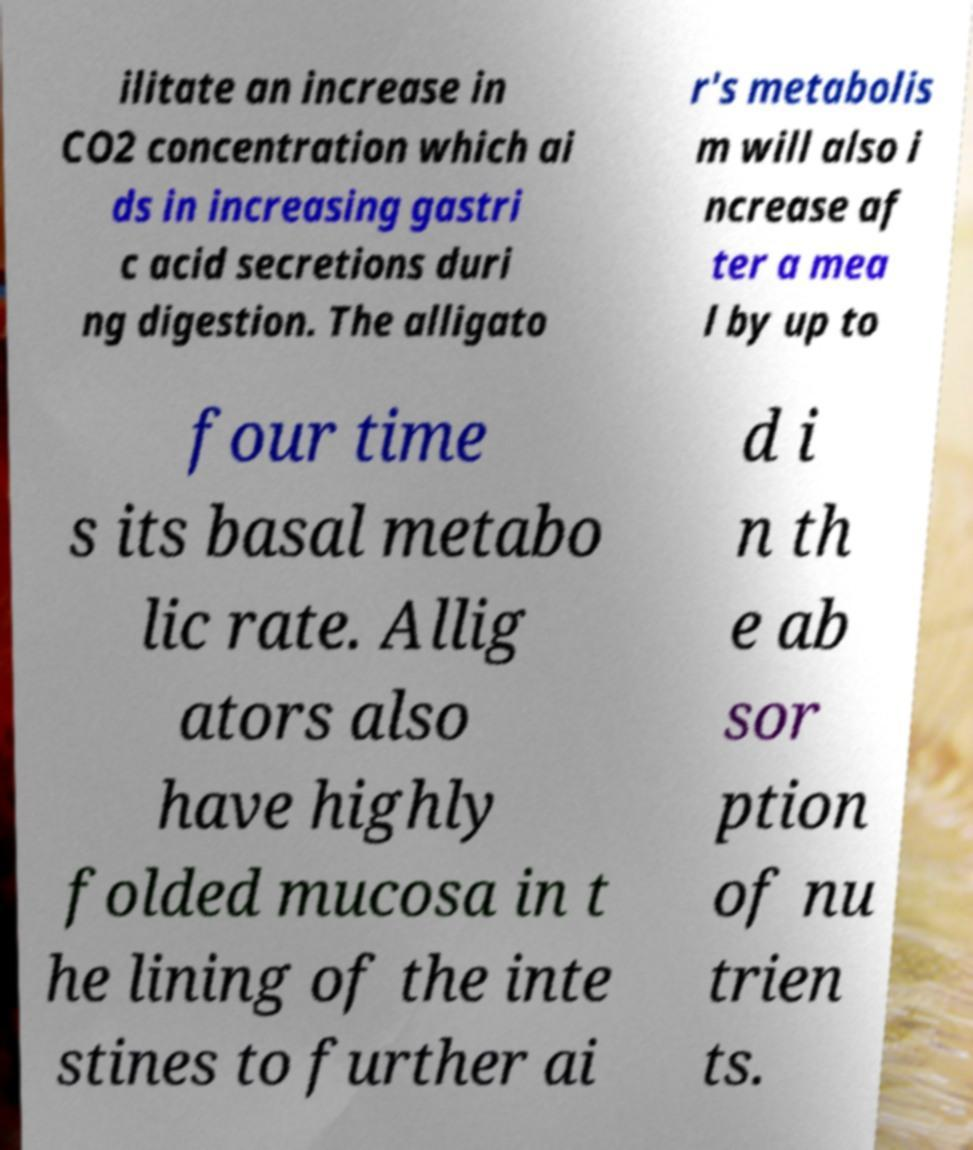Could you extract and type out the text from this image? ilitate an increase in CO2 concentration which ai ds in increasing gastri c acid secretions duri ng digestion. The alligato r's metabolis m will also i ncrease af ter a mea l by up to four time s its basal metabo lic rate. Allig ators also have highly folded mucosa in t he lining of the inte stines to further ai d i n th e ab sor ption of nu trien ts. 